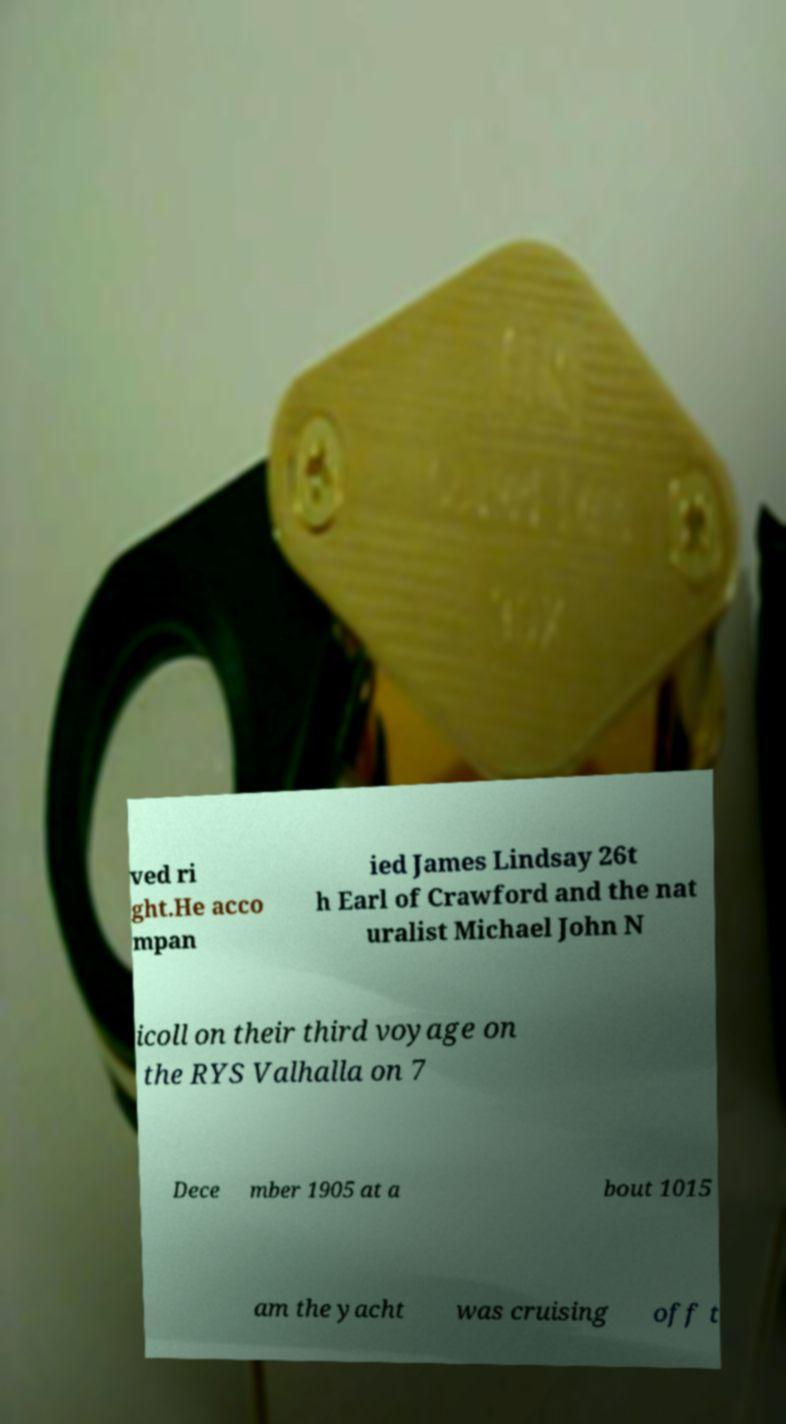For documentation purposes, I need the text within this image transcribed. Could you provide that? ved ri ght.He acco mpan ied James Lindsay 26t h Earl of Crawford and the nat uralist Michael John N icoll on their third voyage on the RYS Valhalla on 7 Dece mber 1905 at a bout 1015 am the yacht was cruising off t 